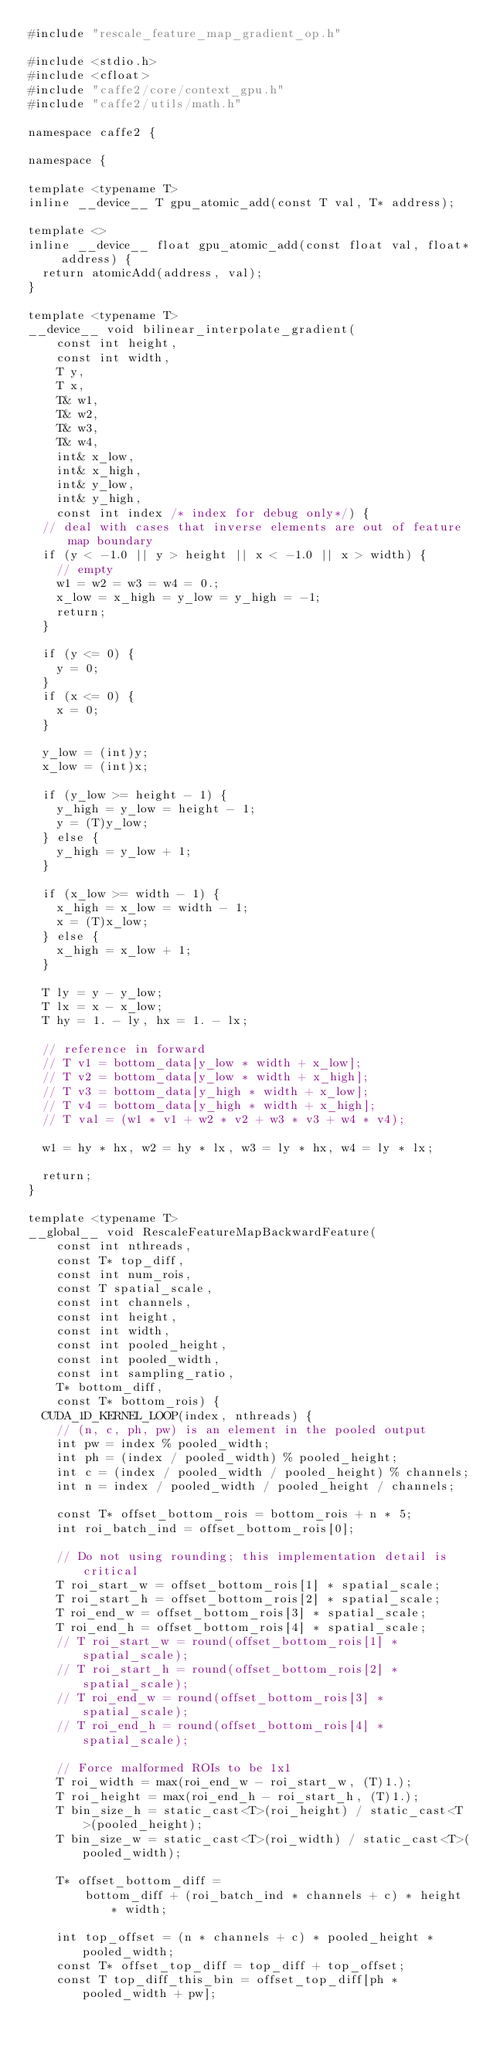Convert code to text. <code><loc_0><loc_0><loc_500><loc_500><_Cuda_>#include "rescale_feature_map_gradient_op.h"

#include <stdio.h>
#include <cfloat>
#include "caffe2/core/context_gpu.h"
#include "caffe2/utils/math.h"

namespace caffe2 {

namespace {

template <typename T>
inline __device__ T gpu_atomic_add(const T val, T* address);

template <>
inline __device__ float gpu_atomic_add(const float val, float* address) {
  return atomicAdd(address, val);
}

template <typename T>
__device__ void bilinear_interpolate_gradient(
    const int height,
    const int width,
    T y,
    T x,
    T& w1,
    T& w2,
    T& w3,
    T& w4,
    int& x_low,
    int& x_high,
    int& y_low,
    int& y_high,
    const int index /* index for debug only*/) {
  // deal with cases that inverse elements are out of feature map boundary
  if (y < -1.0 || y > height || x < -1.0 || x > width) {
    // empty
    w1 = w2 = w3 = w4 = 0.;
    x_low = x_high = y_low = y_high = -1;
    return;
  }

  if (y <= 0) {
    y = 0;
  }
  if (x <= 0) {
    x = 0;
  }

  y_low = (int)y;
  x_low = (int)x;

  if (y_low >= height - 1) {
    y_high = y_low = height - 1;
    y = (T)y_low;
  } else {
    y_high = y_low + 1;
  }

  if (x_low >= width - 1) {
    x_high = x_low = width - 1;
    x = (T)x_low;
  } else {
    x_high = x_low + 1;
  }

  T ly = y - y_low;
  T lx = x - x_low;
  T hy = 1. - ly, hx = 1. - lx;

  // reference in forward
  // T v1 = bottom_data[y_low * width + x_low];
  // T v2 = bottom_data[y_low * width + x_high];
  // T v3 = bottom_data[y_high * width + x_low];
  // T v4 = bottom_data[y_high * width + x_high];
  // T val = (w1 * v1 + w2 * v2 + w3 * v3 + w4 * v4);

  w1 = hy * hx, w2 = hy * lx, w3 = ly * hx, w4 = ly * lx;

  return;
}

template <typename T>
__global__ void RescaleFeatureMapBackwardFeature(
    const int nthreads,
    const T* top_diff,
    const int num_rois,
    const T spatial_scale,
    const int channels,
    const int height,
    const int width,
    const int pooled_height,
    const int pooled_width,
    const int sampling_ratio,
    T* bottom_diff,
    const T* bottom_rois) {
  CUDA_1D_KERNEL_LOOP(index, nthreads) {
    // (n, c, ph, pw) is an element in the pooled output
    int pw = index % pooled_width;
    int ph = (index / pooled_width) % pooled_height;
    int c = (index / pooled_width / pooled_height) % channels;
    int n = index / pooled_width / pooled_height / channels;

    const T* offset_bottom_rois = bottom_rois + n * 5;
    int roi_batch_ind = offset_bottom_rois[0];

    // Do not using rounding; this implementation detail is critical
    T roi_start_w = offset_bottom_rois[1] * spatial_scale;
    T roi_start_h = offset_bottom_rois[2] * spatial_scale;
    T roi_end_w = offset_bottom_rois[3] * spatial_scale;
    T roi_end_h = offset_bottom_rois[4] * spatial_scale;
    // T roi_start_w = round(offset_bottom_rois[1] * spatial_scale);
    // T roi_start_h = round(offset_bottom_rois[2] * spatial_scale);
    // T roi_end_w = round(offset_bottom_rois[3] * spatial_scale);
    // T roi_end_h = round(offset_bottom_rois[4] * spatial_scale);

    // Force malformed ROIs to be 1x1
    T roi_width = max(roi_end_w - roi_start_w, (T)1.);
    T roi_height = max(roi_end_h - roi_start_h, (T)1.);
    T bin_size_h = static_cast<T>(roi_height) / static_cast<T>(pooled_height);
    T bin_size_w = static_cast<T>(roi_width) / static_cast<T>(pooled_width);

    T* offset_bottom_diff =
        bottom_diff + (roi_batch_ind * channels + c) * height * width;

    int top_offset = (n * channels + c) * pooled_height * pooled_width;
    const T* offset_top_diff = top_diff + top_offset;
    const T top_diff_this_bin = offset_top_diff[ph * pooled_width + pw];
</code> 